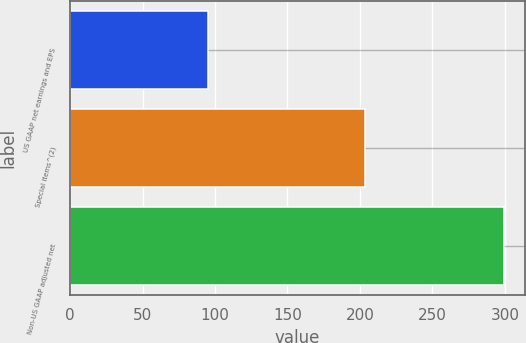Convert chart. <chart><loc_0><loc_0><loc_500><loc_500><bar_chart><fcel>US GAAP net earnings and EPS<fcel>Special items^(2)<fcel>Non-US GAAP adjusted net<nl><fcel>95.3<fcel>203.8<fcel>299.1<nl></chart> 